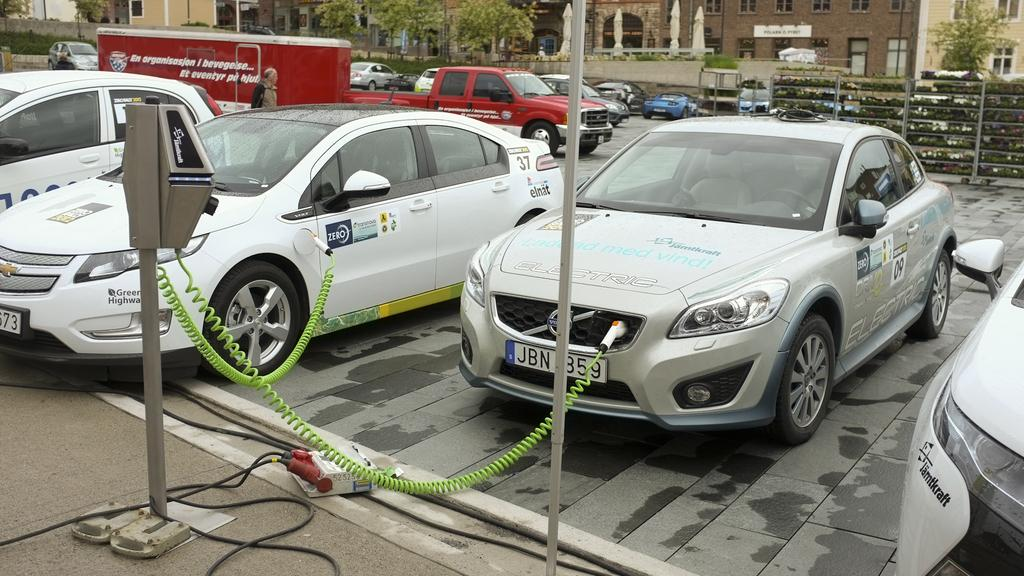What is the main subject of the image? The main subject of the image is a parking area with vehicles. What is the condition of the vehicles in the parking area? The vehicles in the parking area are plugged in. What can be seen in the background of the image? In the background, there are vehicles on a road, trees, and buildings. What type of beam is holding up the tray in the image? There is no beam or tray present in the image. How many women are visible in the image? There are no women visible in the image. 